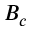<formula> <loc_0><loc_0><loc_500><loc_500>B _ { c }</formula> 